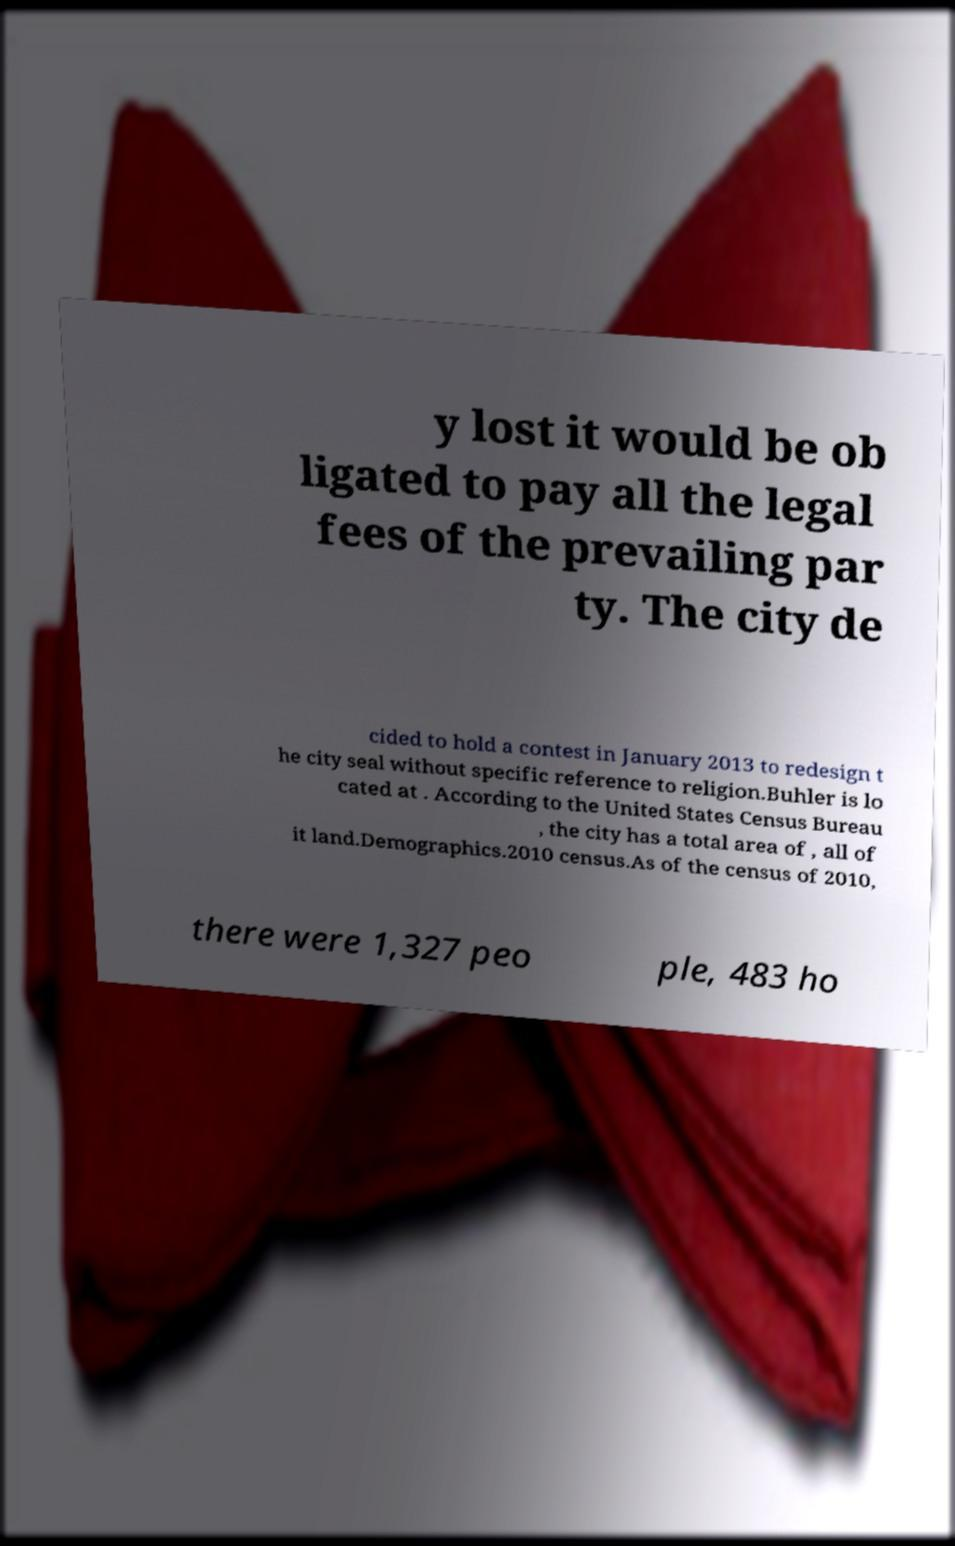There's text embedded in this image that I need extracted. Can you transcribe it verbatim? y lost it would be ob ligated to pay all the legal fees of the prevailing par ty. The city de cided to hold a contest in January 2013 to redesign t he city seal without specific reference to religion.Buhler is lo cated at . According to the United States Census Bureau , the city has a total area of , all of it land.Demographics.2010 census.As of the census of 2010, there were 1,327 peo ple, 483 ho 